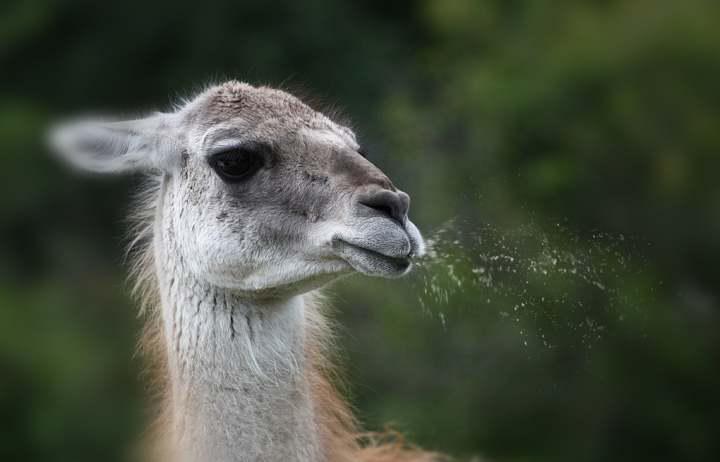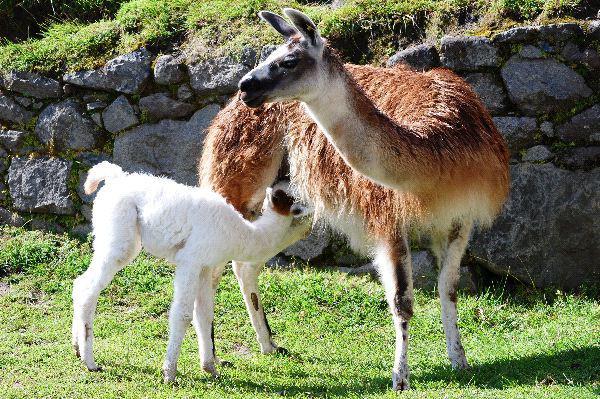The first image is the image on the left, the second image is the image on the right. Examine the images to the left and right. Is the description "The right image includes a small white llama bending its neck toward a bigger shaggy reddish-brown llama." accurate? Answer yes or no. Yes. The first image is the image on the left, the second image is the image on the right. Evaluate the accuracy of this statement regarding the images: "In at least one image there is a baby white llama to the side of its brown mother.". Is it true? Answer yes or no. Yes. 